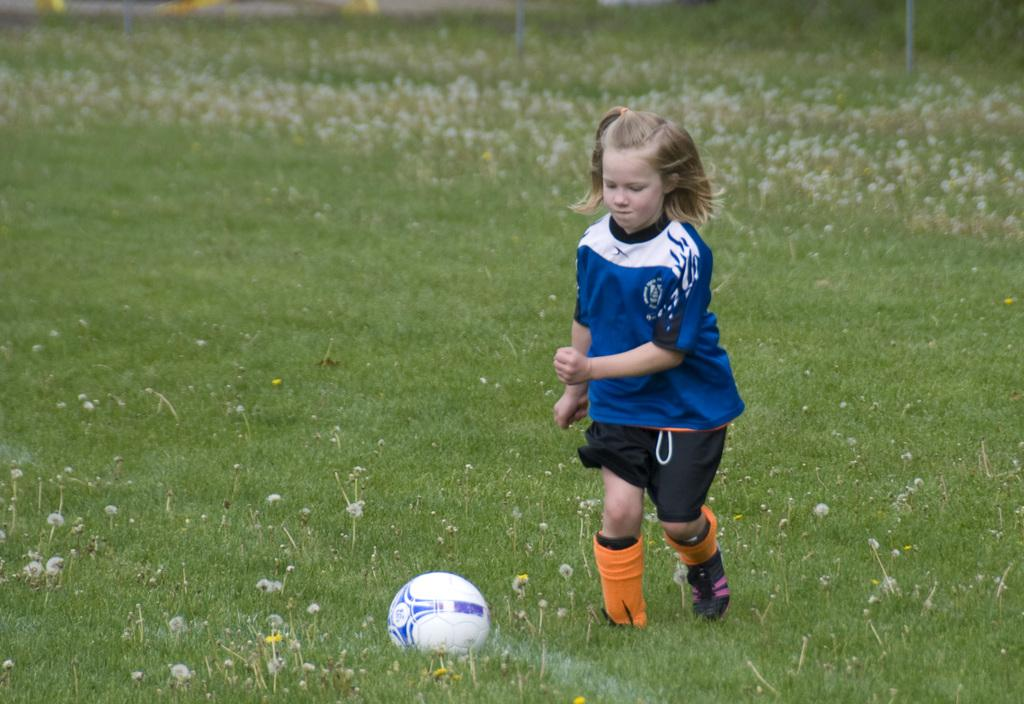What type of vegetation is present in the image? There is grass in the image. What object can be seen in addition to the grass? There is a ball in the image. Who is present in the image? There is a girl in the image. What is the girl wearing? The girl is wearing a blue dress. What type of office equipment can be seen in the image? There is no office equipment present in the image; it features grass, a ball, and a girl in a blue dress. How is the division of labor represented in the image? The image does not depict any division of labor or work-related activities. 